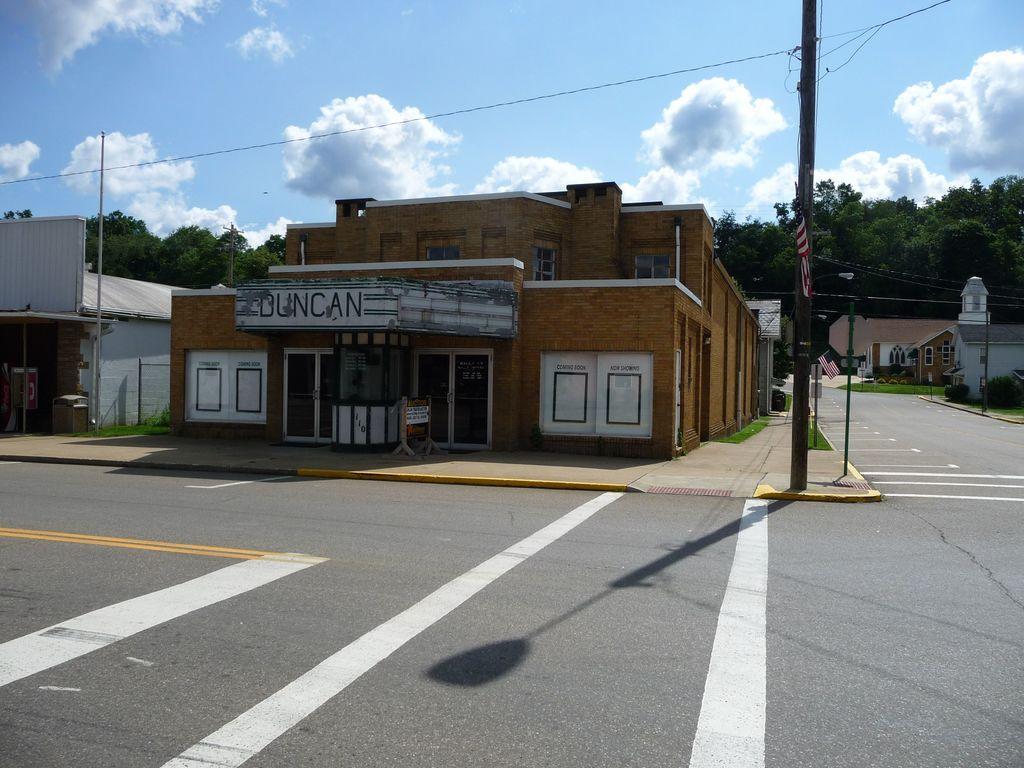Describe this image in one or two sentences. In the foreground of the picture it is road. In the center of the picture there are buildings, street light, footpath, poles, flag and other objects. On the left there are trees, building, pole and cable. On the right there are buildings, plants, grass and trees. At the top it is sky. 